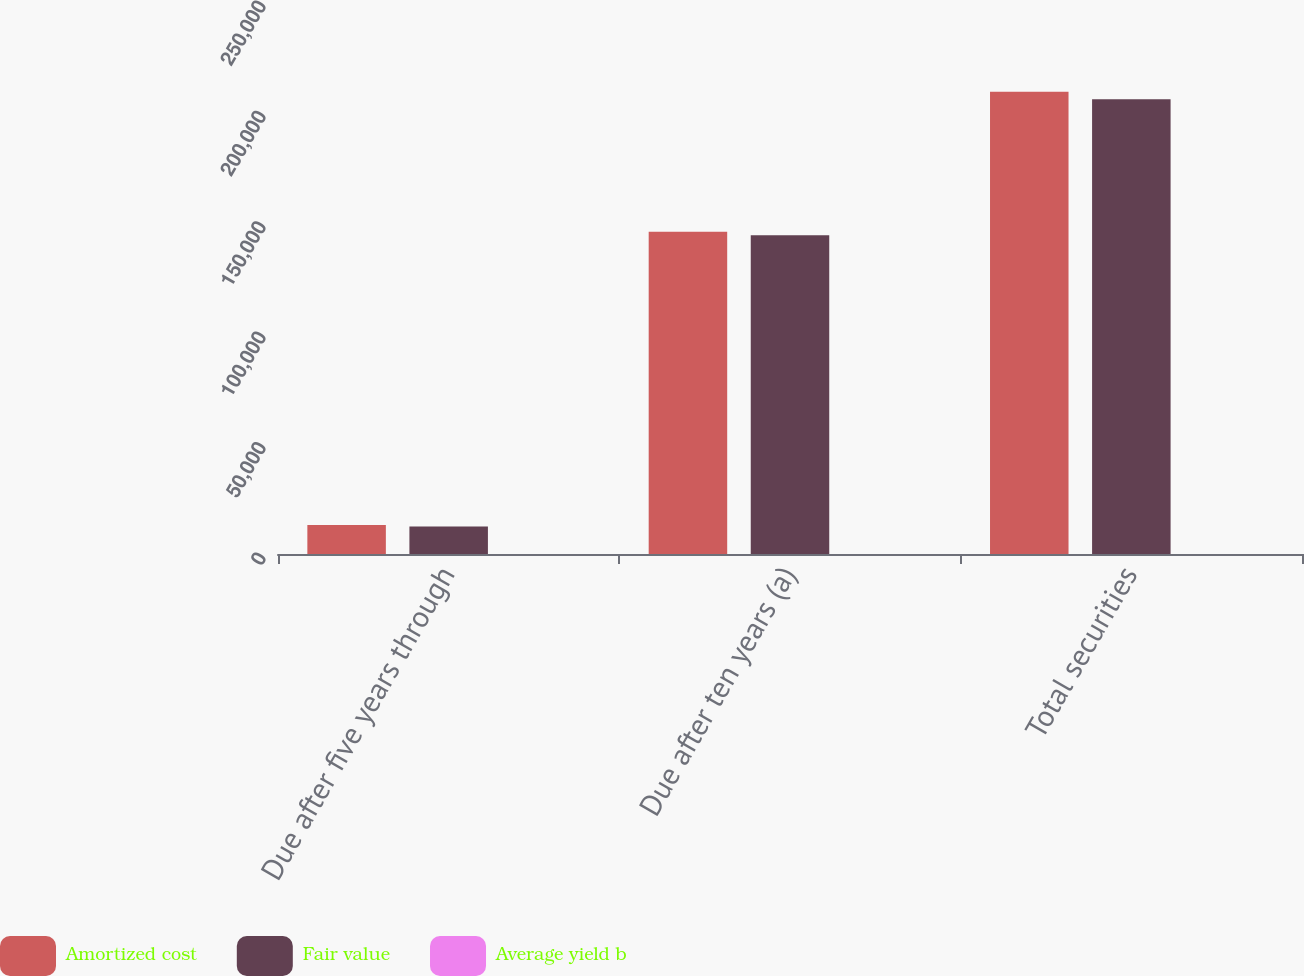Convert chart to OTSL. <chart><loc_0><loc_0><loc_500><loc_500><stacked_bar_chart><ecel><fcel>Due after five years through<fcel>Due after ten years (a)<fcel>Total securities<nl><fcel>Amortized cost<fcel>13105<fcel>145945<fcel>209328<nl><fcel>Fair value<fcel>12436<fcel>144342<fcel>205909<nl><fcel>Average yield b<fcel>3.78<fcel>5.19<fcel>4.49<nl></chart> 